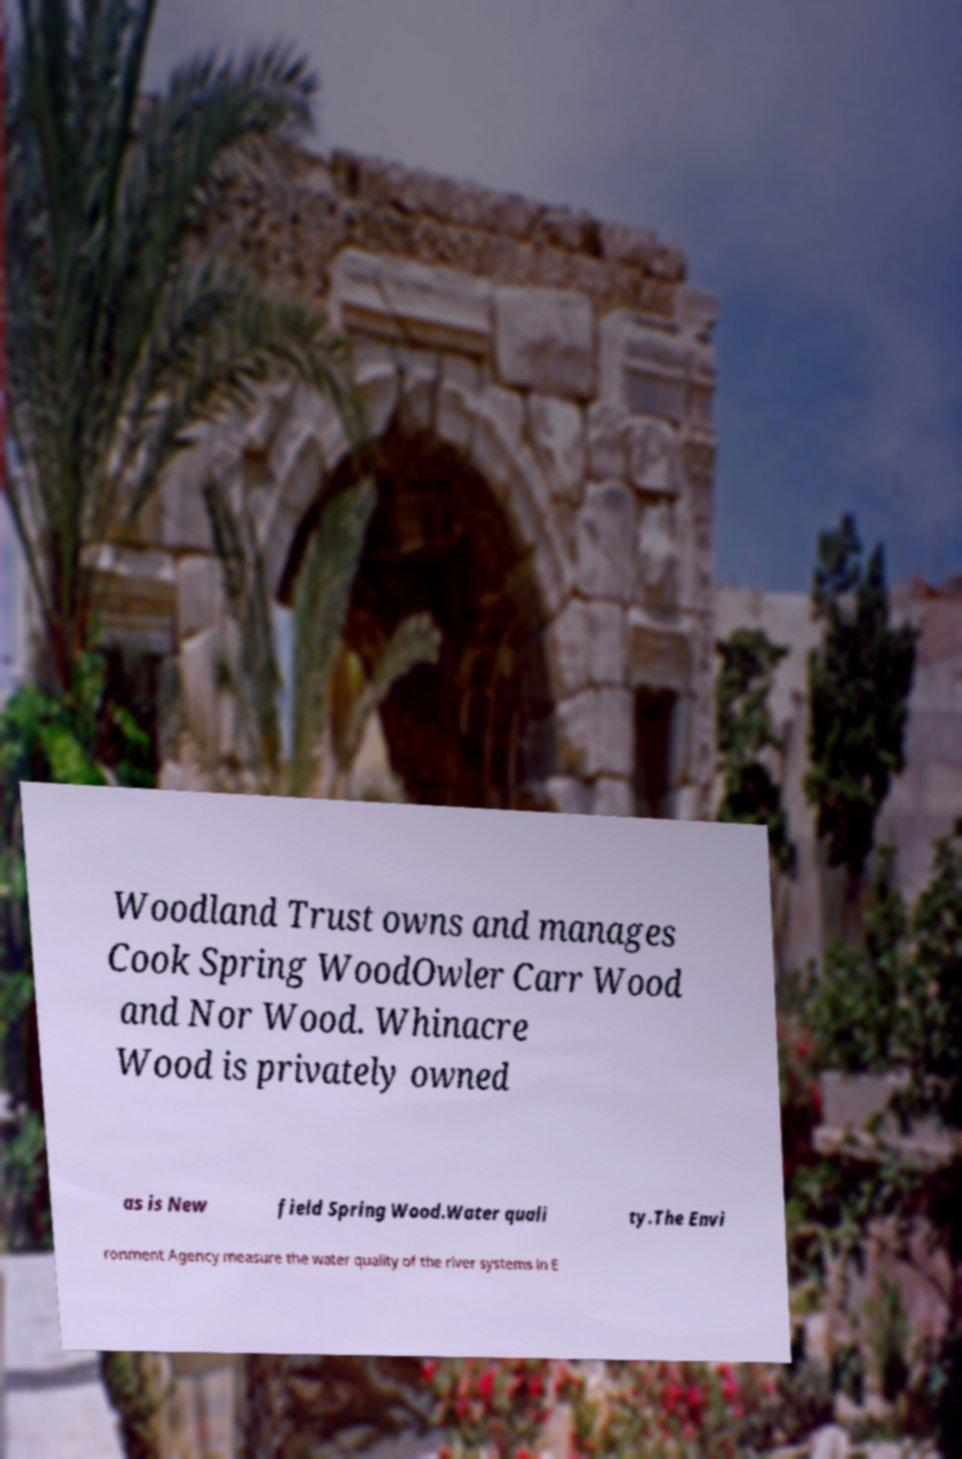What messages or text are displayed in this image? I need them in a readable, typed format. Woodland Trust owns and manages Cook Spring WoodOwler Carr Wood and Nor Wood. Whinacre Wood is privately owned as is New field Spring Wood.Water quali ty.The Envi ronment Agency measure the water quality of the river systems in E 